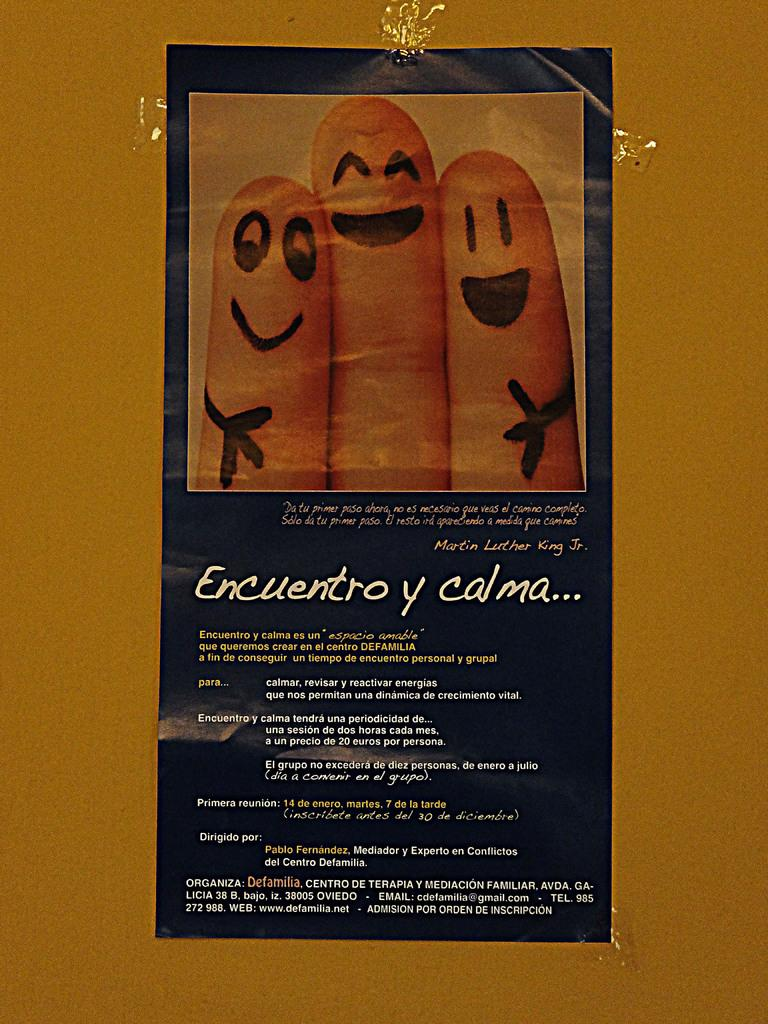What is on the wall in the image? There is a poster on the wall in the image. What can be found on the poster? There is text on the poster. Is there a fold in the poster in the image? There is no information about the poster being folded or unfolded in the image. --- Facts: 1. There is a person sitting on a chair in the image. 2. The person is holding a book. 3. The book has a blue cover. Absurd Topics: dance, swim, parrot Conversation: What is the person in the image doing? The person is sitting on a chair in the image. What is the person holding in the image? The person is holding a book in the image. What can be observed about the book's cover? The book has a blue cover. Reasoning: Let's think step by step in order to produce the conversation. We start by identifying the main subject in the image, which is the person sitting on a chair. Then, we describe the action of the person, which is holding a book. Finally, we provide a detail about the book, which is its blue cover. Each question is designed to elicit a specific detail about the image that is known from the provided facts. Absurd Question/Answer: Is the person in the image dancing while holding the book? There is no indication in the image that the person is dancing; they are sitting on a chair and holding a book. 